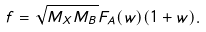<formula> <loc_0><loc_0><loc_500><loc_500>f = \sqrt { M _ { X } M _ { B } } F _ { A } ( w ) ( 1 + w ) .</formula> 